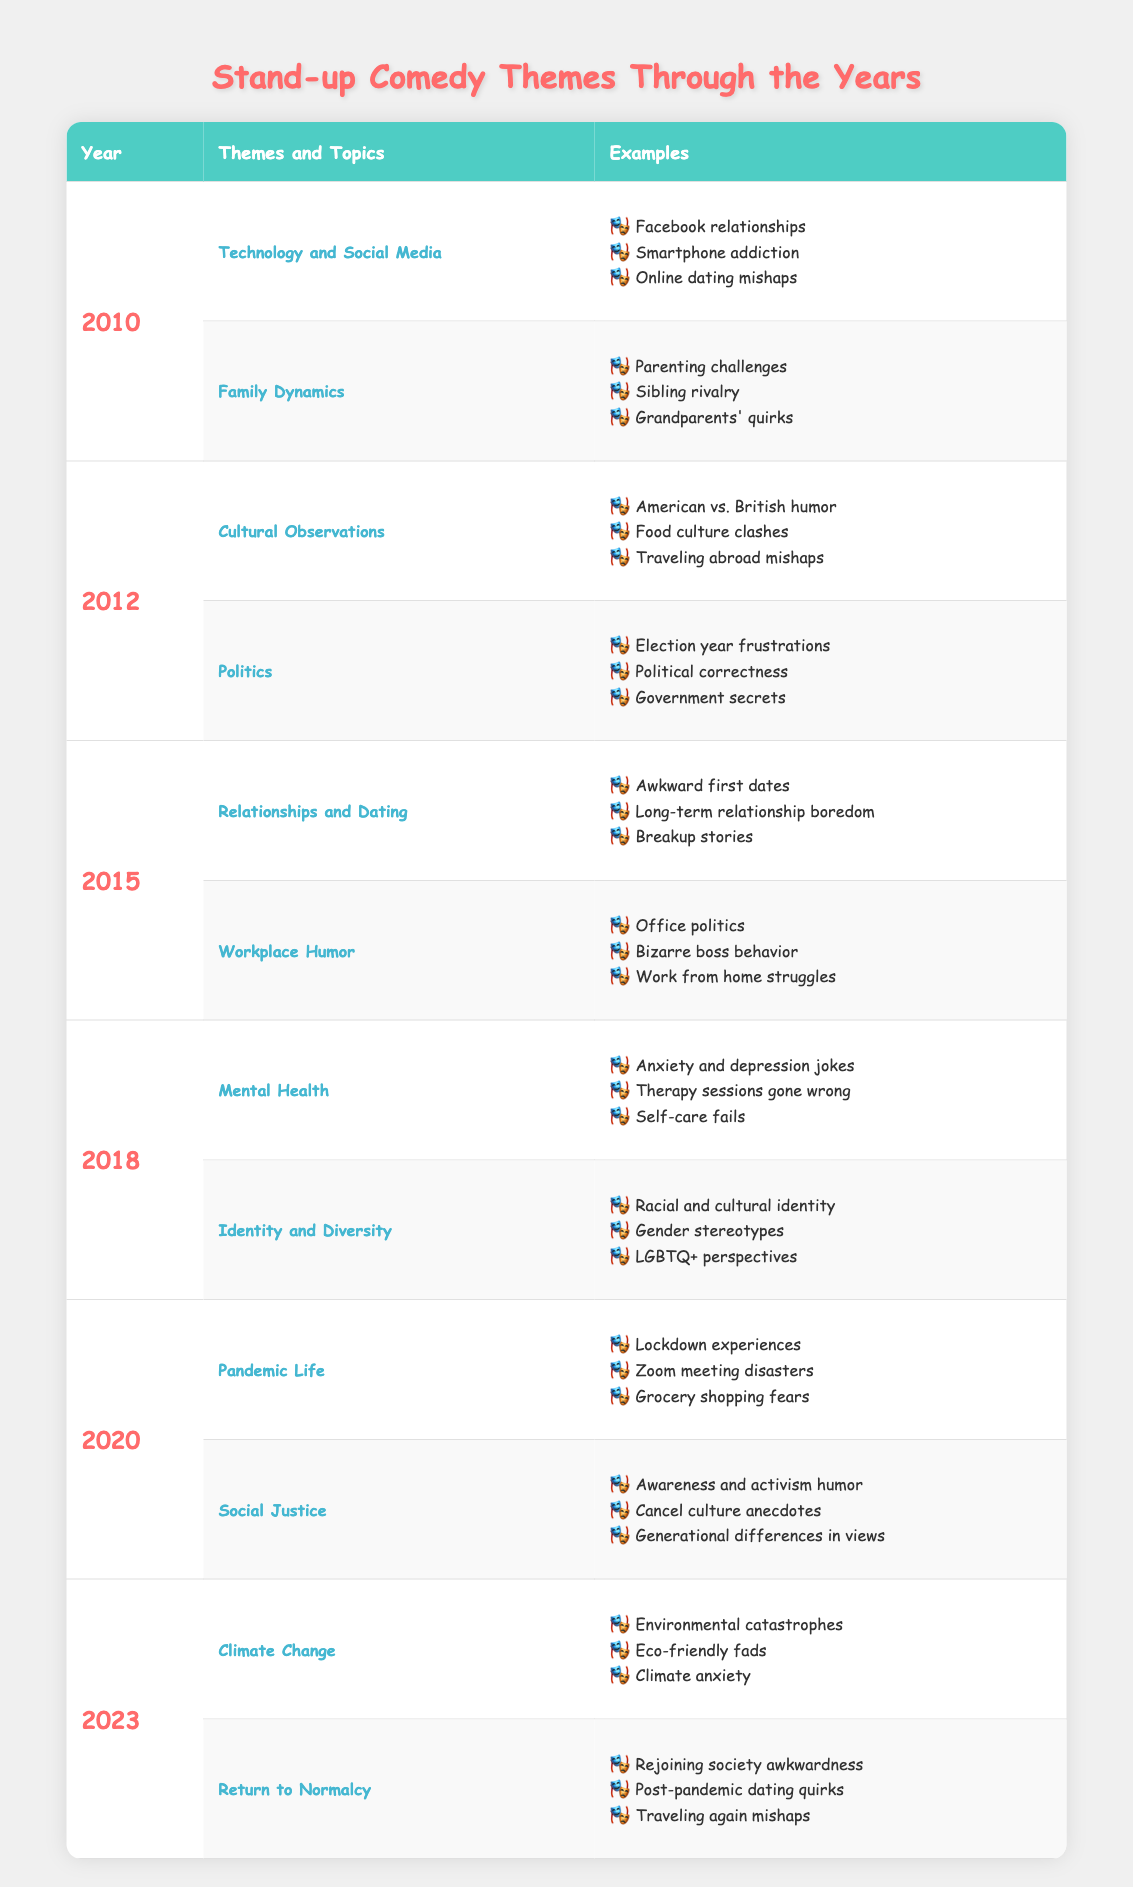What were the main themes in stand-up comedy in 2010? In 2010, the main themes were "Technology and Social Media" and "Family Dynamics."
Answer: Technology and Social Media, Family Dynamics Which year focused on Mental Health in comedy? Mental Health was a focus in 2018 according to the table.
Answer: 2018 What is the relationship between the topics in 2012 and those in 2020? In 2012, the topics were cultural observations and politics, while in 2020 they centered on pandemic life and social justice. The two years highlight different societal issues reflective of their time.
Answer: They are different, focusing on cultural issues vs. pandemic and social justice Was "Office politics" a theme in 2015's comedy routines? Yes, "Office politics" is listed under "Workplace Humor" for the year 2015.
Answer: Yes How many themes were presented in 2018, and how do they compare to 2023? There were 2 themes in 2018 (Mental Health and Identity and Diversity) and 2 themes in 2023 (Climate Change and Return to Normalcy), making them equal in number.
Answer: 2 themes each What topics were addressed in stand-up comedy during pandemic years? The topics during pandemic years (2020) included "Pandemic Life" and "Social Justice," reflecting societal changes due to the pandemic.
Answer: Pandemic Life, Social Justice Did the stand-up comedy themes of 2010 and 2015 share any common topics? No, the themes of 2010 (Technology and Social Media, Family Dynamics) and 2015 (Relationships and Dating, Workplace Humor) do not overlap.
Answer: No Which themes evolved in the comedy scene from 2012 to 2023? From 2012 to 2023, themes evolved from observations on culture and politics to contemporary issues like climate change and societal readjustment post-pandemic, showing a shift towards environmental and social concerns.
Answer: Evolved to contemporary issues like climate change and social adjustment How many examples of themes related to technology does the table provide in total? In 2010 under "Technology and Social Media," there are 3 examples provided. Thus, there are a total of 3 examples related to technology regarding themes.
Answer: 3 examples 